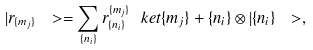Convert formula to latex. <formula><loc_0><loc_0><loc_500><loc_500>| r _ { \{ m _ { j } \} } \ > = \sum _ { \{ n _ { i } \} } r ^ { \{ m _ { j } \} } _ { \{ n _ { i } \} } \ k e t { \{ m _ { j } \} + \{ n _ { i } \} } \otimes | \{ n _ { i } \} \ > ,</formula> 